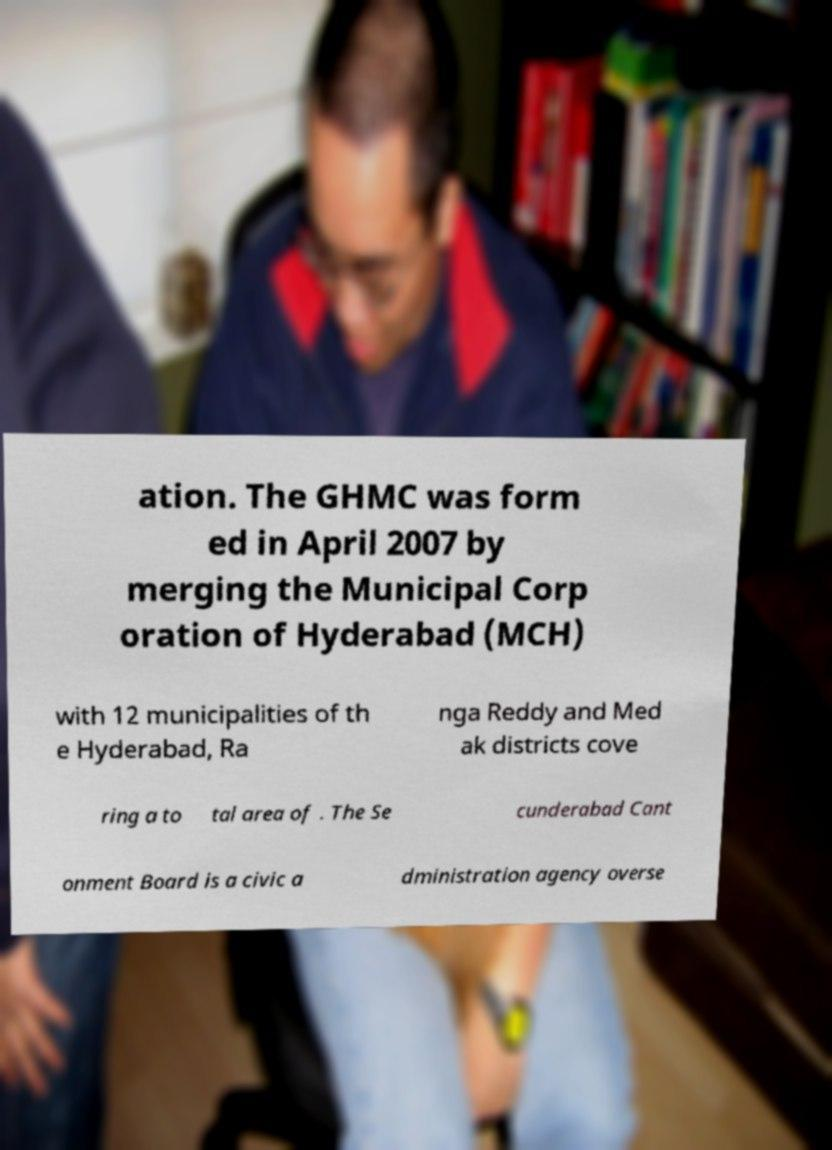Please read and relay the text visible in this image. What does it say? ation. The GHMC was form ed in April 2007 by merging the Municipal Corp oration of Hyderabad (MCH) with 12 municipalities of th e Hyderabad, Ra nga Reddy and Med ak districts cove ring a to tal area of . The Se cunderabad Cant onment Board is a civic a dministration agency overse 